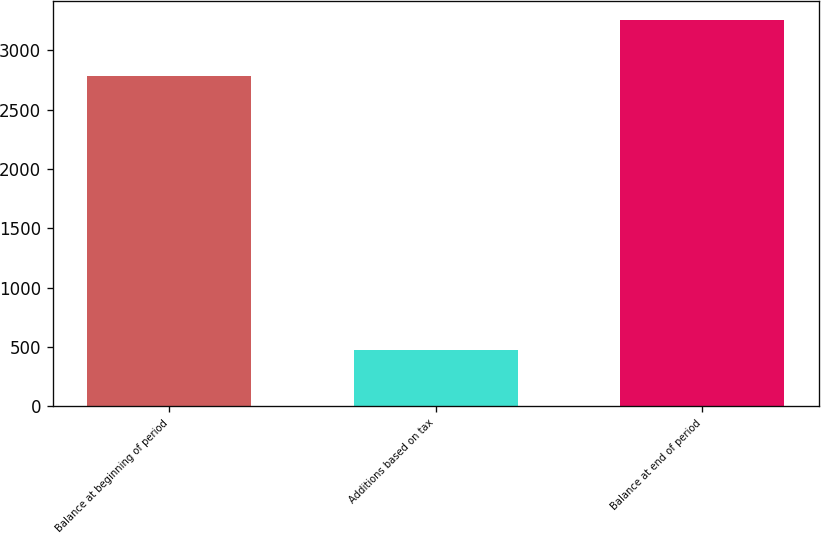Convert chart to OTSL. <chart><loc_0><loc_0><loc_500><loc_500><bar_chart><fcel>Balance at beginning of period<fcel>Additions based on tax<fcel>Balance at end of period<nl><fcel>2784<fcel>469<fcel>3253<nl></chart> 